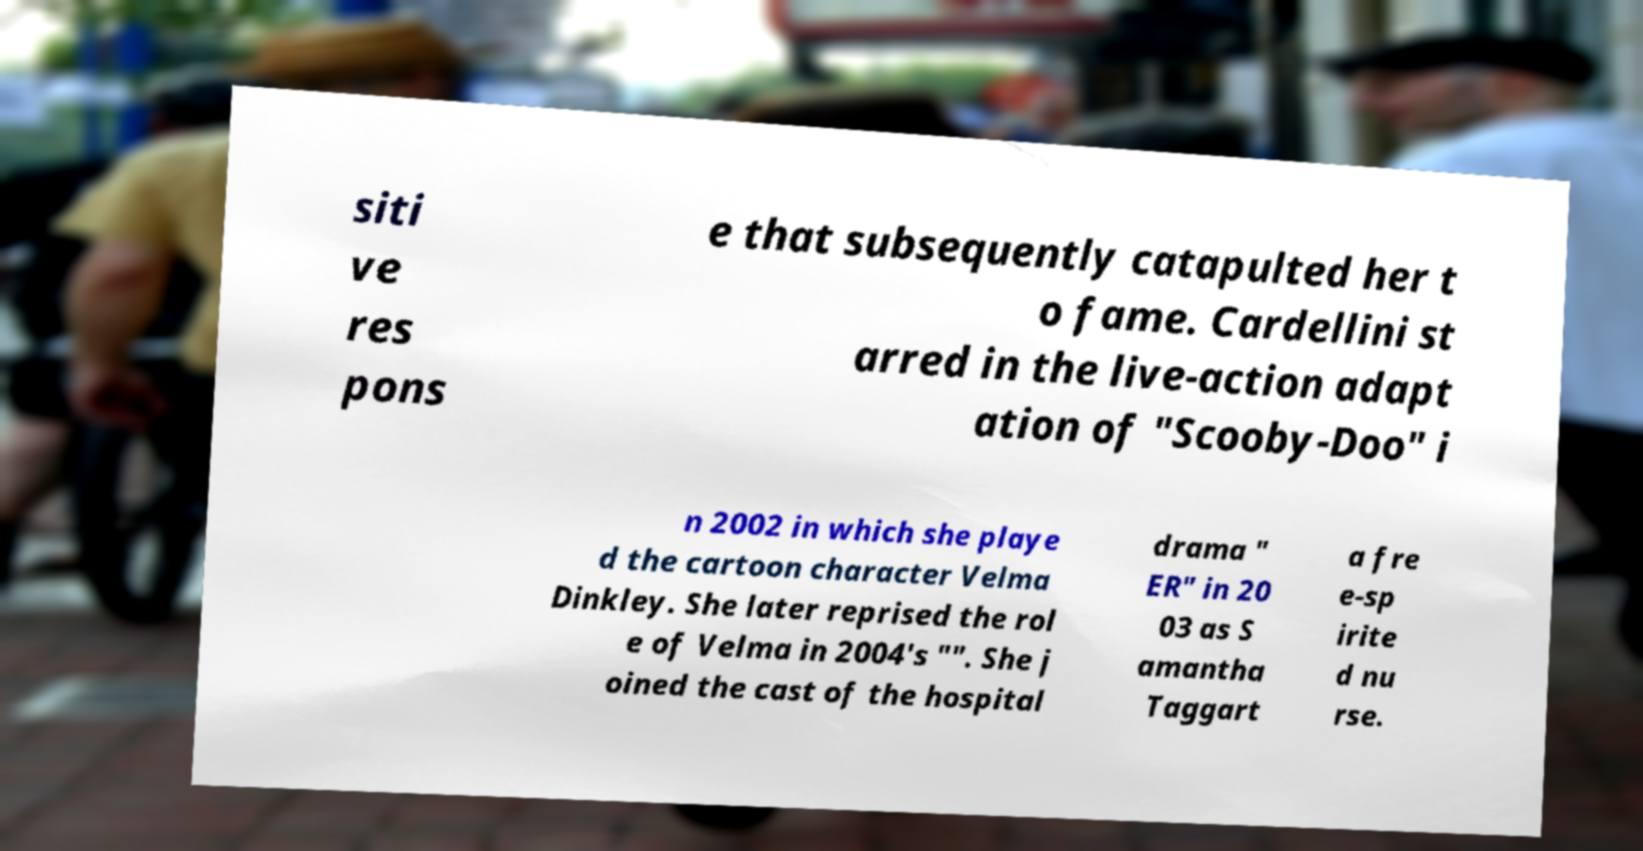For documentation purposes, I need the text within this image transcribed. Could you provide that? siti ve res pons e that subsequently catapulted her t o fame. Cardellini st arred in the live-action adapt ation of "Scooby-Doo" i n 2002 in which she playe d the cartoon character Velma Dinkley. She later reprised the rol e of Velma in 2004's "". She j oined the cast of the hospital drama " ER" in 20 03 as S amantha Taggart a fre e-sp irite d nu rse. 